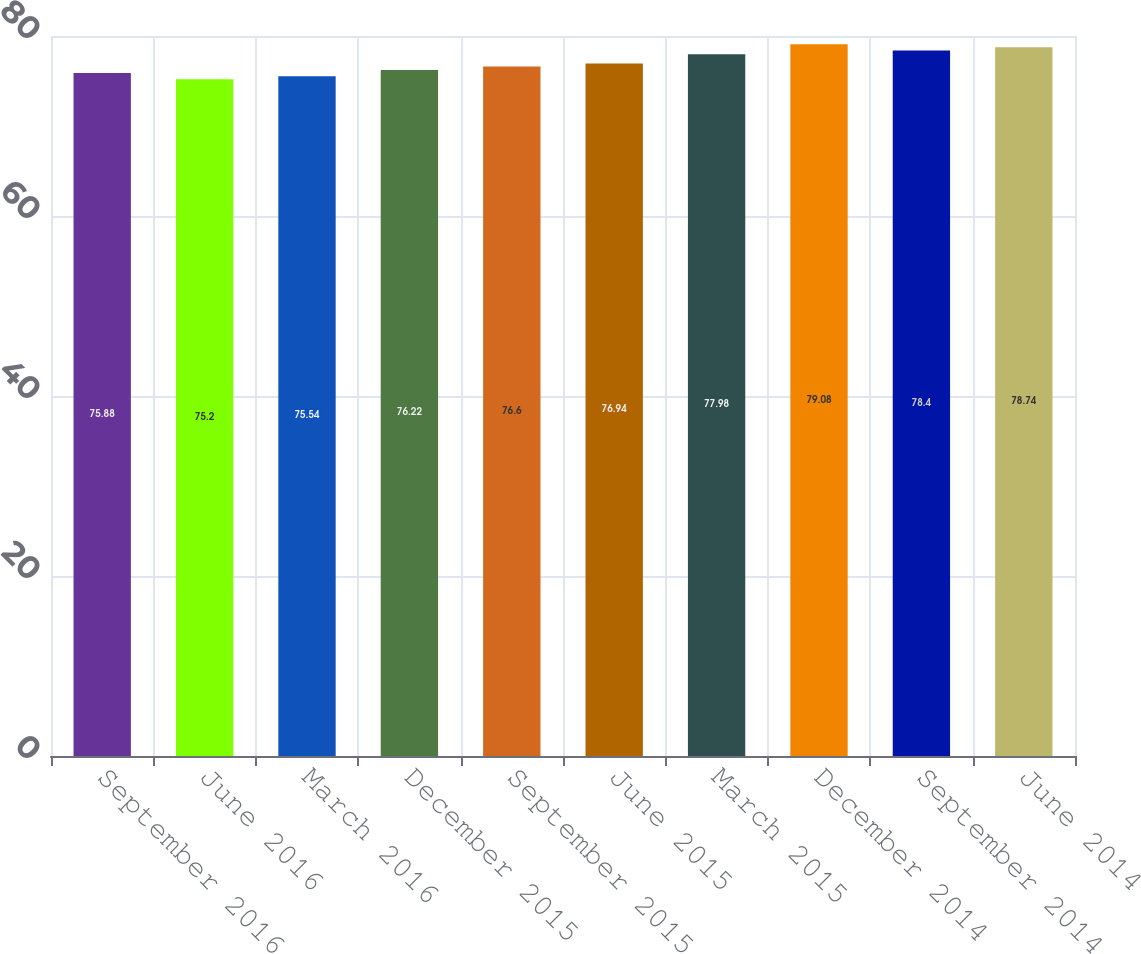Convert chart to OTSL. <chart><loc_0><loc_0><loc_500><loc_500><bar_chart><fcel>September 2016<fcel>June 2016<fcel>March 2016<fcel>December 2015<fcel>September 2015<fcel>June 2015<fcel>March 2015<fcel>December 2014<fcel>September 2014<fcel>June 2014<nl><fcel>75.88<fcel>75.2<fcel>75.54<fcel>76.22<fcel>76.6<fcel>76.94<fcel>77.98<fcel>79.08<fcel>78.4<fcel>78.74<nl></chart> 